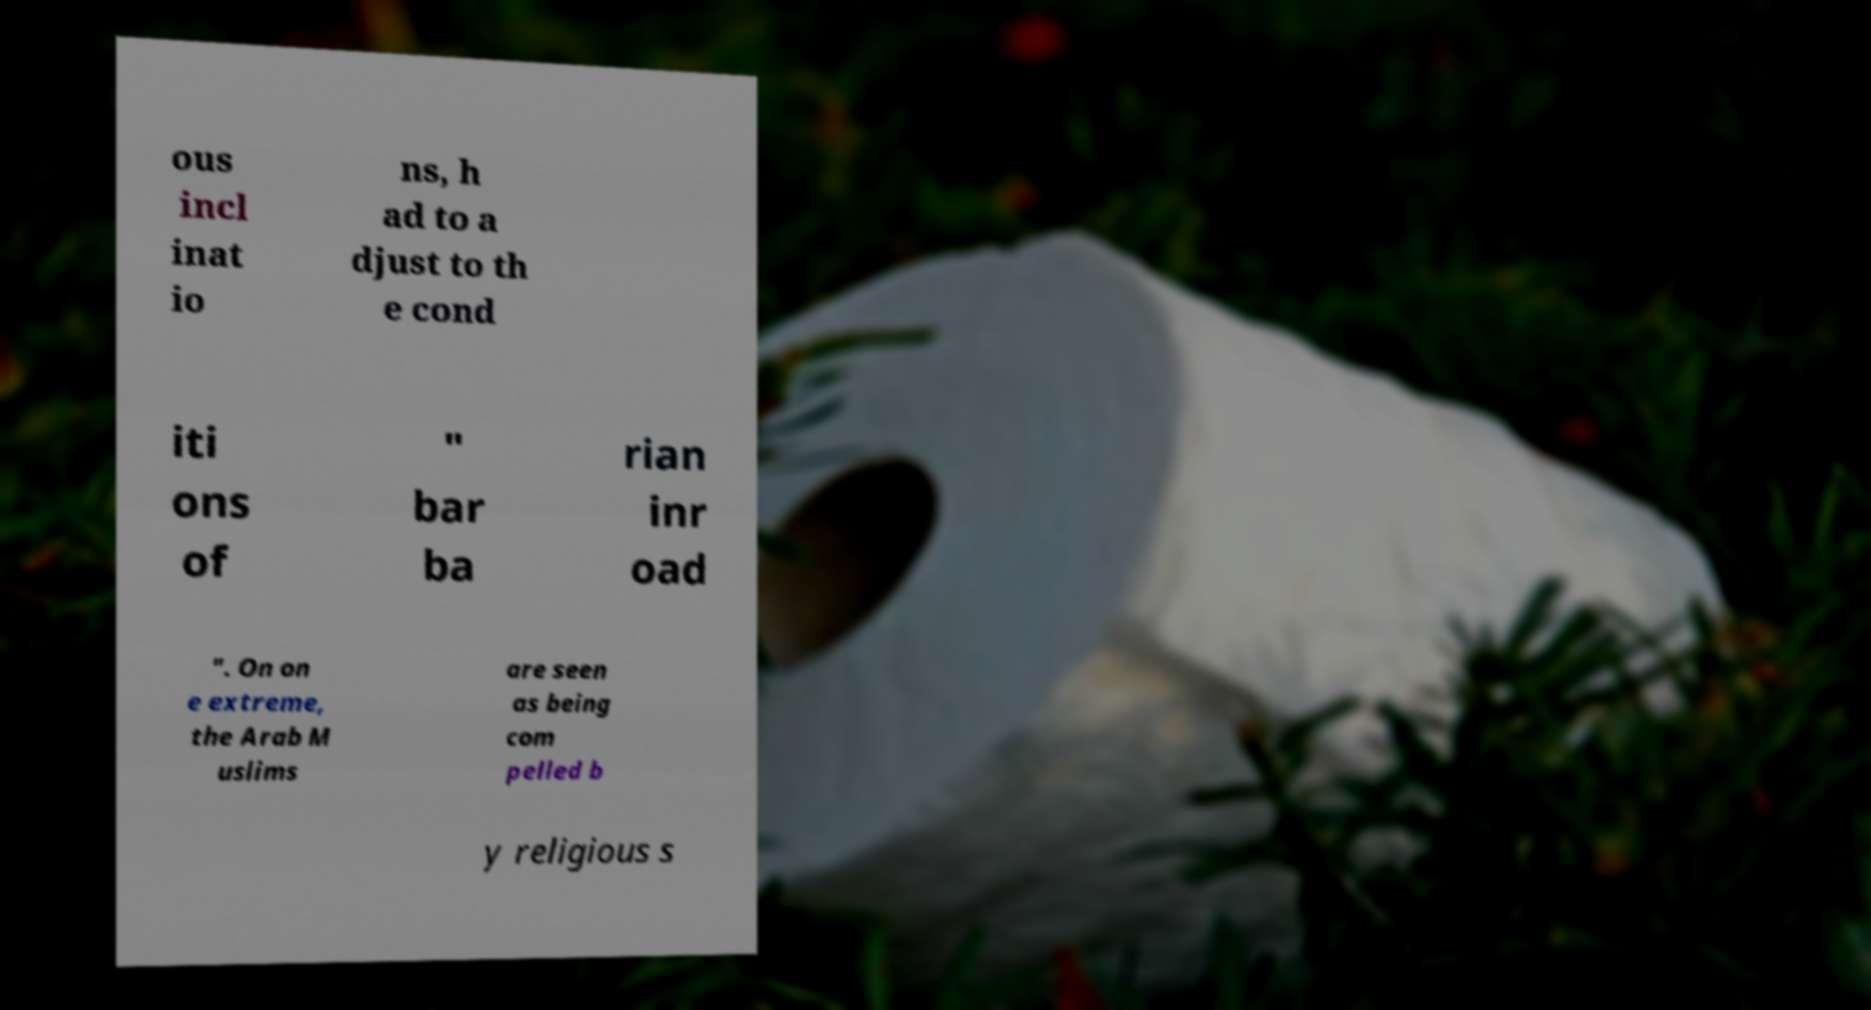What messages or text are displayed in this image? I need them in a readable, typed format. ous incl inat io ns, h ad to a djust to th e cond iti ons of " bar ba rian inr oad ". On on e extreme, the Arab M uslims are seen as being com pelled b y religious s 